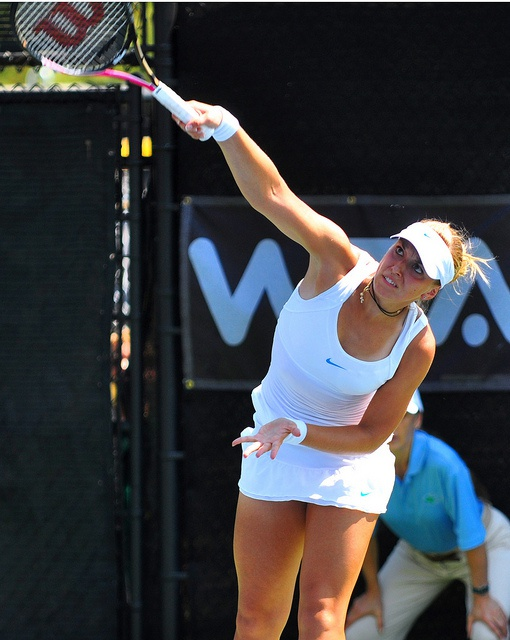Describe the objects in this image and their specific colors. I can see people in white, brown, and lightblue tones, people in white, gray, teal, lightblue, and blue tones, and tennis racket in white, black, gray, darkgray, and lavender tones in this image. 